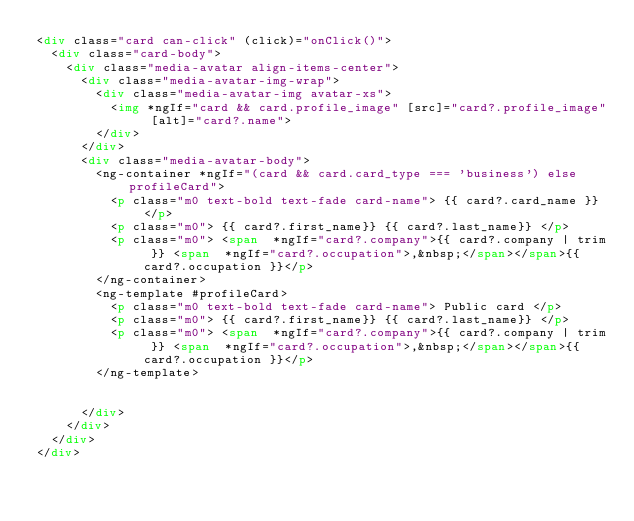<code> <loc_0><loc_0><loc_500><loc_500><_HTML_><div class="card can-click" (click)="onClick()">
  <div class="card-body">
    <div class="media-avatar align-items-center">
      <div class="media-avatar-img-wrap">
        <div class="media-avatar-img avatar-xs">
          <img *ngIf="card && card.profile_image" [src]="card?.profile_image" [alt]="card?.name">
        </div>
      </div>
      <div class="media-avatar-body">
        <ng-container *ngIf="(card && card.card_type === 'business') else profileCard">
          <p class="m0 text-bold text-fade card-name"> {{ card?.card_name }} </p>
          <p class="m0"> {{ card?.first_name}} {{ card?.last_name}} </p>
          <p class="m0"> <span  *ngIf="card?.company">{{ card?.company | trim }} <span  *ngIf="card?.occupation">,&nbsp;</span></span>{{ card?.occupation }}</p>
        </ng-container>
        <ng-template #profileCard>
          <p class="m0 text-bold text-fade card-name"> Public card </p>
          <p class="m0"> {{ card?.first_name}} {{ card?.last_name}} </p>
          <p class="m0"> <span  *ngIf="card?.company">{{ card?.company | trim }} <span  *ngIf="card?.occupation">,&nbsp;</span></span>{{ card?.occupation }}</p>
        </ng-template>


      </div>
    </div>
  </div>
</div>
      
</code> 